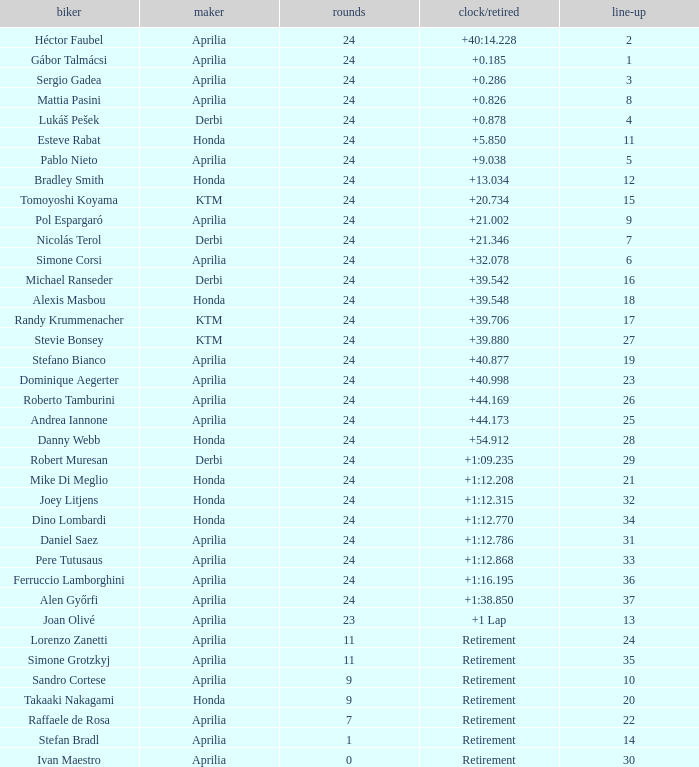208? None. 